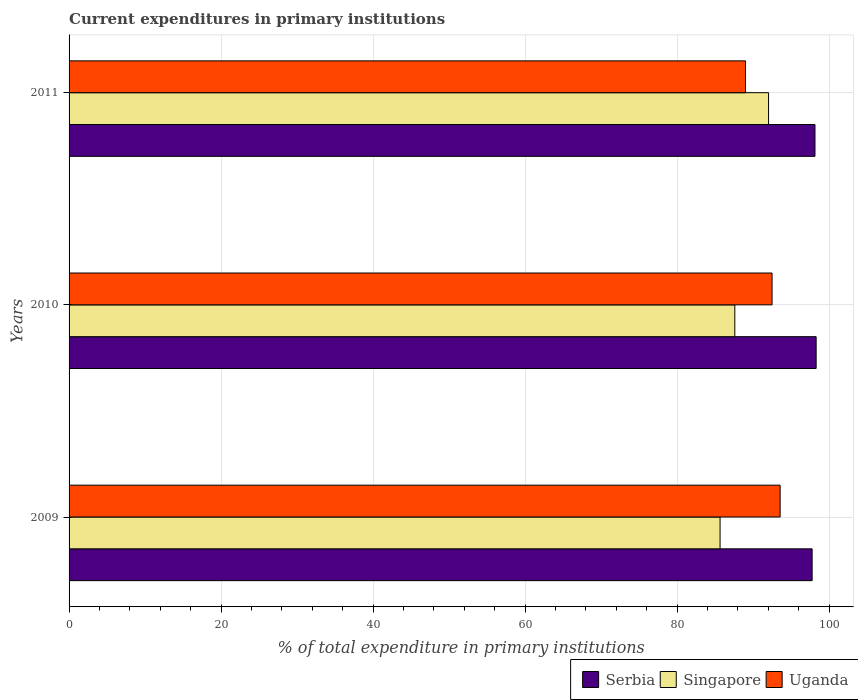How many groups of bars are there?
Your answer should be very brief. 3. How many bars are there on the 2nd tick from the top?
Offer a very short reply. 3. What is the label of the 3rd group of bars from the top?
Give a very brief answer. 2009. What is the current expenditures in primary institutions in Serbia in 2009?
Your answer should be very brief. 97.76. Across all years, what is the maximum current expenditures in primary institutions in Uganda?
Offer a very short reply. 93.55. Across all years, what is the minimum current expenditures in primary institutions in Singapore?
Ensure brevity in your answer.  85.64. In which year was the current expenditures in primary institutions in Uganda maximum?
Your response must be concise. 2009. What is the total current expenditures in primary institutions in Uganda in the graph?
Provide a short and direct response. 275.02. What is the difference between the current expenditures in primary institutions in Serbia in 2009 and that in 2010?
Your answer should be very brief. -0.53. What is the difference between the current expenditures in primary institutions in Singapore in 2009 and the current expenditures in primary institutions in Uganda in 2011?
Offer a terse response. -3.35. What is the average current expenditures in primary institutions in Singapore per year?
Provide a short and direct response. 88.42. In the year 2010, what is the difference between the current expenditures in primary institutions in Serbia and current expenditures in primary institutions in Singapore?
Offer a very short reply. 10.7. What is the ratio of the current expenditures in primary institutions in Serbia in 2009 to that in 2010?
Provide a succinct answer. 0.99. Is the current expenditures in primary institutions in Uganda in 2009 less than that in 2010?
Give a very brief answer. No. Is the difference between the current expenditures in primary institutions in Serbia in 2009 and 2011 greater than the difference between the current expenditures in primary institutions in Singapore in 2009 and 2011?
Your answer should be very brief. Yes. What is the difference between the highest and the second highest current expenditures in primary institutions in Serbia?
Keep it short and to the point. 0.15. What is the difference between the highest and the lowest current expenditures in primary institutions in Singapore?
Your answer should be very brief. 6.38. In how many years, is the current expenditures in primary institutions in Singapore greater than the average current expenditures in primary institutions in Singapore taken over all years?
Give a very brief answer. 1. What does the 2nd bar from the top in 2009 represents?
Offer a very short reply. Singapore. What does the 2nd bar from the bottom in 2009 represents?
Your answer should be very brief. Singapore. How many bars are there?
Give a very brief answer. 9. Are all the bars in the graph horizontal?
Give a very brief answer. Yes. How many years are there in the graph?
Provide a succinct answer. 3. Does the graph contain grids?
Your response must be concise. Yes. What is the title of the graph?
Your response must be concise. Current expenditures in primary institutions. Does "Guyana" appear as one of the legend labels in the graph?
Your answer should be very brief. No. What is the label or title of the X-axis?
Your answer should be very brief. % of total expenditure in primary institutions. What is the % of total expenditure in primary institutions of Serbia in 2009?
Give a very brief answer. 97.76. What is the % of total expenditure in primary institutions in Singapore in 2009?
Make the answer very short. 85.64. What is the % of total expenditure in primary institutions of Uganda in 2009?
Your answer should be compact. 93.55. What is the % of total expenditure in primary institutions of Serbia in 2010?
Your answer should be very brief. 98.28. What is the % of total expenditure in primary institutions in Singapore in 2010?
Provide a short and direct response. 87.58. What is the % of total expenditure in primary institutions in Uganda in 2010?
Your answer should be compact. 92.48. What is the % of total expenditure in primary institutions of Serbia in 2011?
Ensure brevity in your answer.  98.13. What is the % of total expenditure in primary institutions in Singapore in 2011?
Provide a succinct answer. 92.02. What is the % of total expenditure in primary institutions of Uganda in 2011?
Give a very brief answer. 88.99. Across all years, what is the maximum % of total expenditure in primary institutions in Serbia?
Provide a short and direct response. 98.28. Across all years, what is the maximum % of total expenditure in primary institutions of Singapore?
Give a very brief answer. 92.02. Across all years, what is the maximum % of total expenditure in primary institutions in Uganda?
Your answer should be very brief. 93.55. Across all years, what is the minimum % of total expenditure in primary institutions of Serbia?
Provide a short and direct response. 97.76. Across all years, what is the minimum % of total expenditure in primary institutions of Singapore?
Your response must be concise. 85.64. Across all years, what is the minimum % of total expenditure in primary institutions of Uganda?
Keep it short and to the point. 88.99. What is the total % of total expenditure in primary institutions of Serbia in the graph?
Keep it short and to the point. 294.17. What is the total % of total expenditure in primary institutions in Singapore in the graph?
Offer a terse response. 265.25. What is the total % of total expenditure in primary institutions of Uganda in the graph?
Ensure brevity in your answer.  275.02. What is the difference between the % of total expenditure in primary institutions of Serbia in 2009 and that in 2010?
Ensure brevity in your answer.  -0.53. What is the difference between the % of total expenditure in primary institutions in Singapore in 2009 and that in 2010?
Make the answer very short. -1.94. What is the difference between the % of total expenditure in primary institutions in Uganda in 2009 and that in 2010?
Make the answer very short. 1.06. What is the difference between the % of total expenditure in primary institutions of Serbia in 2009 and that in 2011?
Offer a very short reply. -0.37. What is the difference between the % of total expenditure in primary institutions in Singapore in 2009 and that in 2011?
Your response must be concise. -6.38. What is the difference between the % of total expenditure in primary institutions in Uganda in 2009 and that in 2011?
Make the answer very short. 4.55. What is the difference between the % of total expenditure in primary institutions of Serbia in 2010 and that in 2011?
Your response must be concise. 0.15. What is the difference between the % of total expenditure in primary institutions in Singapore in 2010 and that in 2011?
Keep it short and to the point. -4.44. What is the difference between the % of total expenditure in primary institutions in Uganda in 2010 and that in 2011?
Ensure brevity in your answer.  3.49. What is the difference between the % of total expenditure in primary institutions in Serbia in 2009 and the % of total expenditure in primary institutions in Singapore in 2010?
Provide a short and direct response. 10.17. What is the difference between the % of total expenditure in primary institutions in Serbia in 2009 and the % of total expenditure in primary institutions in Uganda in 2010?
Give a very brief answer. 5.27. What is the difference between the % of total expenditure in primary institutions in Singapore in 2009 and the % of total expenditure in primary institutions in Uganda in 2010?
Keep it short and to the point. -6.84. What is the difference between the % of total expenditure in primary institutions in Serbia in 2009 and the % of total expenditure in primary institutions in Singapore in 2011?
Your answer should be compact. 5.73. What is the difference between the % of total expenditure in primary institutions of Serbia in 2009 and the % of total expenditure in primary institutions of Uganda in 2011?
Keep it short and to the point. 8.76. What is the difference between the % of total expenditure in primary institutions of Singapore in 2009 and the % of total expenditure in primary institutions of Uganda in 2011?
Make the answer very short. -3.35. What is the difference between the % of total expenditure in primary institutions in Serbia in 2010 and the % of total expenditure in primary institutions in Singapore in 2011?
Give a very brief answer. 6.26. What is the difference between the % of total expenditure in primary institutions of Serbia in 2010 and the % of total expenditure in primary institutions of Uganda in 2011?
Make the answer very short. 9.29. What is the difference between the % of total expenditure in primary institutions in Singapore in 2010 and the % of total expenditure in primary institutions in Uganda in 2011?
Your response must be concise. -1.41. What is the average % of total expenditure in primary institutions of Serbia per year?
Keep it short and to the point. 98.06. What is the average % of total expenditure in primary institutions of Singapore per year?
Give a very brief answer. 88.42. What is the average % of total expenditure in primary institutions of Uganda per year?
Offer a very short reply. 91.67. In the year 2009, what is the difference between the % of total expenditure in primary institutions of Serbia and % of total expenditure in primary institutions of Singapore?
Provide a succinct answer. 12.11. In the year 2009, what is the difference between the % of total expenditure in primary institutions in Serbia and % of total expenditure in primary institutions in Uganda?
Make the answer very short. 4.21. In the year 2009, what is the difference between the % of total expenditure in primary institutions of Singapore and % of total expenditure in primary institutions of Uganda?
Offer a terse response. -7.9. In the year 2010, what is the difference between the % of total expenditure in primary institutions in Serbia and % of total expenditure in primary institutions in Singapore?
Provide a short and direct response. 10.7. In the year 2010, what is the difference between the % of total expenditure in primary institutions of Serbia and % of total expenditure in primary institutions of Uganda?
Make the answer very short. 5.8. In the year 2010, what is the difference between the % of total expenditure in primary institutions in Singapore and % of total expenditure in primary institutions in Uganda?
Your response must be concise. -4.9. In the year 2011, what is the difference between the % of total expenditure in primary institutions of Serbia and % of total expenditure in primary institutions of Singapore?
Your response must be concise. 6.11. In the year 2011, what is the difference between the % of total expenditure in primary institutions of Serbia and % of total expenditure in primary institutions of Uganda?
Ensure brevity in your answer.  9.14. In the year 2011, what is the difference between the % of total expenditure in primary institutions of Singapore and % of total expenditure in primary institutions of Uganda?
Ensure brevity in your answer.  3.03. What is the ratio of the % of total expenditure in primary institutions in Singapore in 2009 to that in 2010?
Provide a short and direct response. 0.98. What is the ratio of the % of total expenditure in primary institutions of Uganda in 2009 to that in 2010?
Keep it short and to the point. 1.01. What is the ratio of the % of total expenditure in primary institutions in Singapore in 2009 to that in 2011?
Your response must be concise. 0.93. What is the ratio of the % of total expenditure in primary institutions in Uganda in 2009 to that in 2011?
Ensure brevity in your answer.  1.05. What is the ratio of the % of total expenditure in primary institutions of Singapore in 2010 to that in 2011?
Make the answer very short. 0.95. What is the ratio of the % of total expenditure in primary institutions in Uganda in 2010 to that in 2011?
Provide a succinct answer. 1.04. What is the difference between the highest and the second highest % of total expenditure in primary institutions in Serbia?
Provide a succinct answer. 0.15. What is the difference between the highest and the second highest % of total expenditure in primary institutions of Singapore?
Provide a short and direct response. 4.44. What is the difference between the highest and the second highest % of total expenditure in primary institutions of Uganda?
Keep it short and to the point. 1.06. What is the difference between the highest and the lowest % of total expenditure in primary institutions of Serbia?
Provide a succinct answer. 0.53. What is the difference between the highest and the lowest % of total expenditure in primary institutions of Singapore?
Provide a short and direct response. 6.38. What is the difference between the highest and the lowest % of total expenditure in primary institutions in Uganda?
Provide a short and direct response. 4.55. 